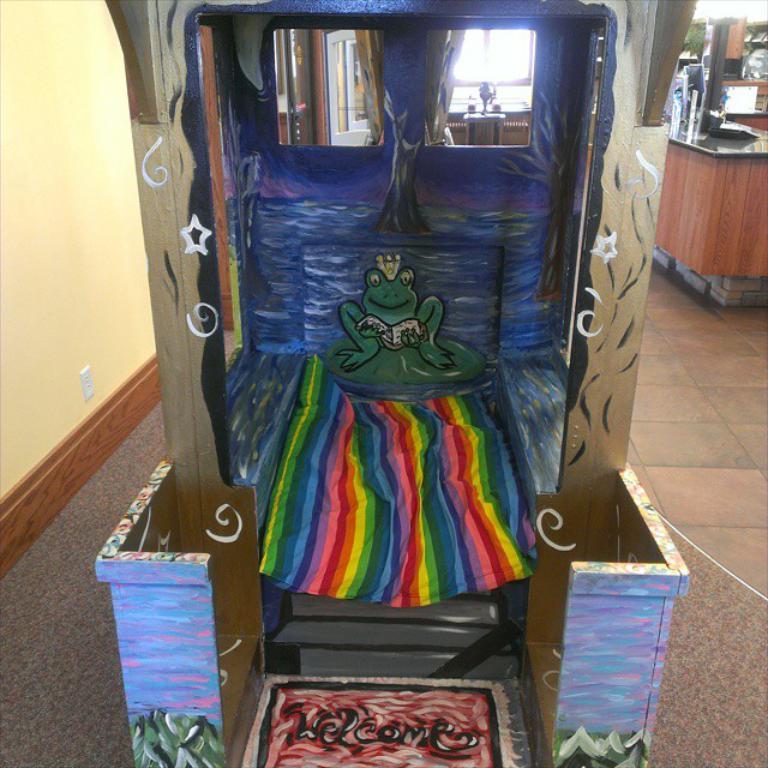Describe this image in one or two sentences. In this image we can see the wooden object and some painting on it, we can see the cloth, two mirrors, on the left we can see the wall, on the right we can see the wooden table and few objects on it. 